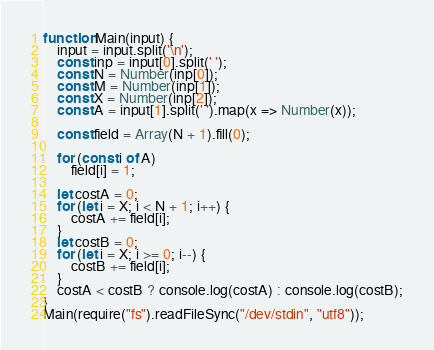Convert code to text. <code><loc_0><loc_0><loc_500><loc_500><_TypeScript_>function Main(input) {
    input = input.split('\n');
    const inp = input[0].split(' ');
    const N = Number(inp[0]);
    const M = Number(inp[1]);
    const X = Number(inp[2]);
    const A = input[1].split(' ').map(x => Number(x));

    const field = Array(N + 1).fill(0);

    for (const i of A)
        field[i] = 1;

    let costA = 0;
    for (let i = X; i < N + 1; i++) {
        costA += field[i];
    }
    let costB = 0;
    for (let i = X; i >= 0; i--) {
        costB += field[i];
    }
    costA < costB ? console.log(costA) : console.log(costB);
}
Main(require("fs").readFileSync("/dev/stdin", "utf8"));</code> 